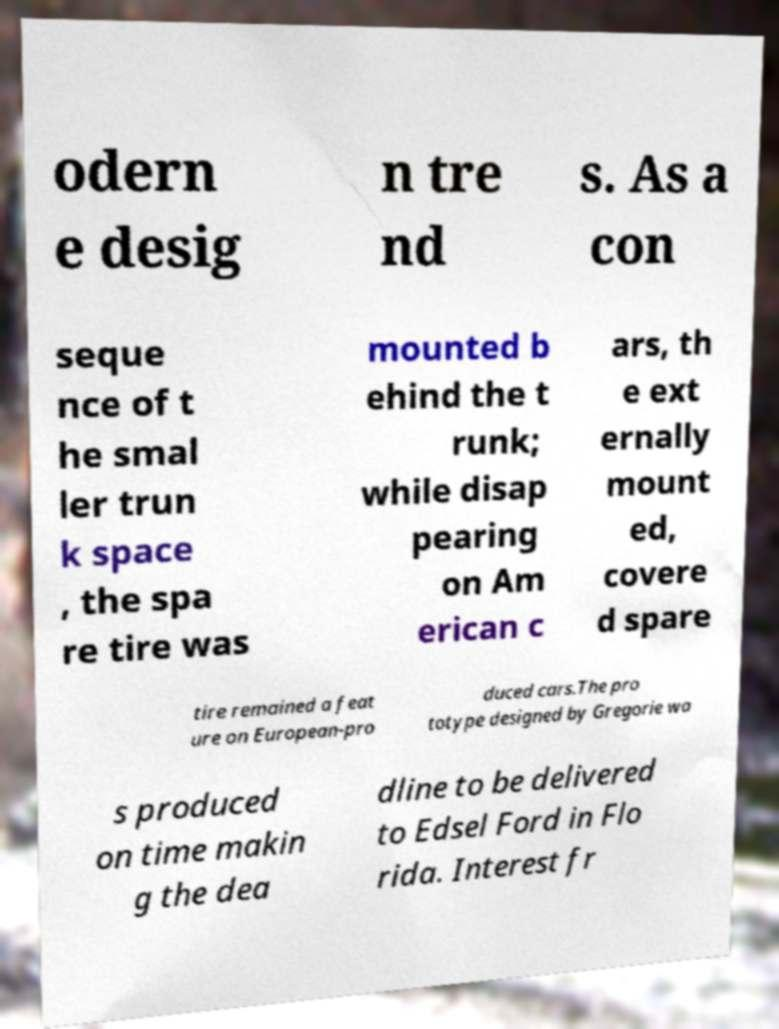I need the written content from this picture converted into text. Can you do that? odern e desig n tre nd s. As a con seque nce of t he smal ler trun k space , the spa re tire was mounted b ehind the t runk; while disap pearing on Am erican c ars, th e ext ernally mount ed, covere d spare tire remained a feat ure on European-pro duced cars.The pro totype designed by Gregorie wa s produced on time makin g the dea dline to be delivered to Edsel Ford in Flo rida. Interest fr 